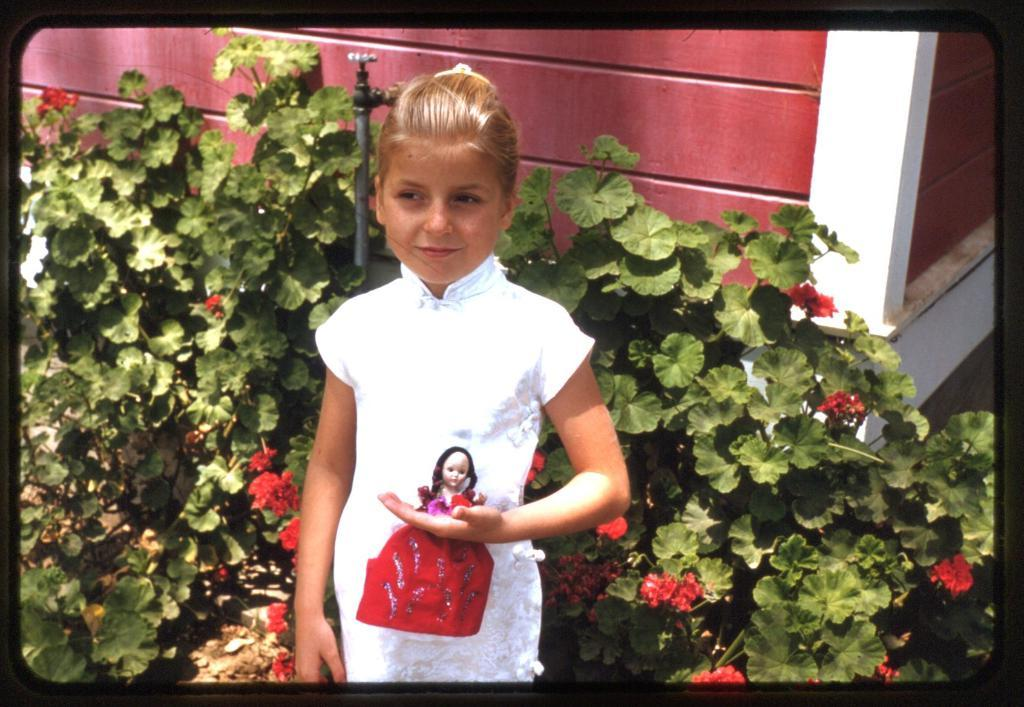Who is the main subject in the image? There is a girl in the image. What is the girl holding in her hand? The girl is holding a doll in her hand. What can be seen in the background behind the girl? There are flowers and leaves of a plant visible behind the girl. What is the purpose of the object on the wall in the image? There is a tap on the wall in the image, which is likely used for water. How does the girl make a request to the board in the image? There is no board present in the image, so the girl cannot make a request to it. 